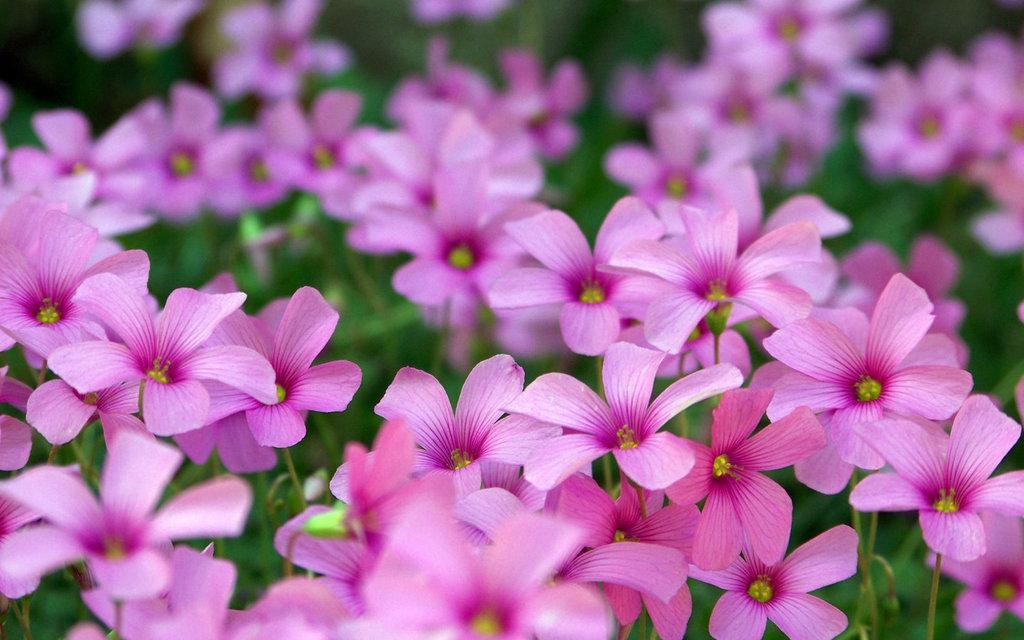Please provide a concise description of this image. In this image we can see some flowers. In the background of the image there is a blur background. 